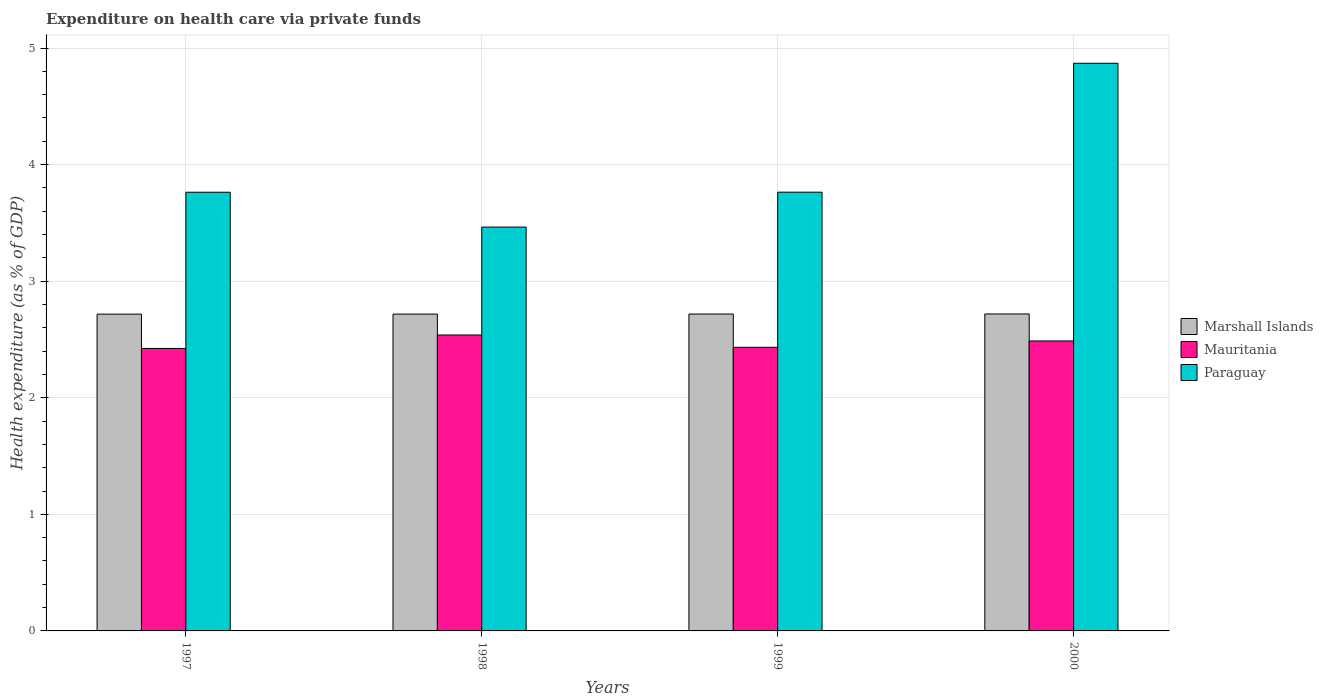How many groups of bars are there?
Your response must be concise. 4. Are the number of bars on each tick of the X-axis equal?
Provide a short and direct response. Yes. How many bars are there on the 2nd tick from the left?
Your answer should be very brief. 3. How many bars are there on the 3rd tick from the right?
Keep it short and to the point. 3. What is the expenditure made on health care in Paraguay in 1997?
Offer a very short reply. 3.76. Across all years, what is the maximum expenditure made on health care in Mauritania?
Your response must be concise. 2.54. Across all years, what is the minimum expenditure made on health care in Mauritania?
Your answer should be compact. 2.42. In which year was the expenditure made on health care in Paraguay maximum?
Your answer should be very brief. 2000. What is the total expenditure made on health care in Mauritania in the graph?
Keep it short and to the point. 9.88. What is the difference between the expenditure made on health care in Marshall Islands in 1997 and that in 1999?
Provide a short and direct response. -0. What is the difference between the expenditure made on health care in Marshall Islands in 2000 and the expenditure made on health care in Mauritania in 1998?
Your answer should be very brief. 0.18. What is the average expenditure made on health care in Mauritania per year?
Your answer should be compact. 2.47. In the year 1997, what is the difference between the expenditure made on health care in Paraguay and expenditure made on health care in Marshall Islands?
Provide a succinct answer. 1.05. In how many years, is the expenditure made on health care in Paraguay greater than 2.4 %?
Your response must be concise. 4. What is the ratio of the expenditure made on health care in Mauritania in 1997 to that in 2000?
Make the answer very short. 0.97. Is the difference between the expenditure made on health care in Paraguay in 1998 and 1999 greater than the difference between the expenditure made on health care in Marshall Islands in 1998 and 1999?
Ensure brevity in your answer.  No. What is the difference between the highest and the second highest expenditure made on health care in Marshall Islands?
Ensure brevity in your answer.  0. What is the difference between the highest and the lowest expenditure made on health care in Paraguay?
Offer a terse response. 1.41. Is the sum of the expenditure made on health care in Marshall Islands in 1997 and 2000 greater than the maximum expenditure made on health care in Paraguay across all years?
Keep it short and to the point. Yes. What does the 1st bar from the left in 1999 represents?
Make the answer very short. Marshall Islands. What does the 2nd bar from the right in 2000 represents?
Offer a terse response. Mauritania. How many years are there in the graph?
Provide a succinct answer. 4. What is the difference between two consecutive major ticks on the Y-axis?
Ensure brevity in your answer.  1. Are the values on the major ticks of Y-axis written in scientific E-notation?
Provide a short and direct response. No. Does the graph contain grids?
Make the answer very short. Yes. What is the title of the graph?
Offer a very short reply. Expenditure on health care via private funds. Does "Syrian Arab Republic" appear as one of the legend labels in the graph?
Provide a succinct answer. No. What is the label or title of the Y-axis?
Your response must be concise. Health expenditure (as % of GDP). What is the Health expenditure (as % of GDP) of Marshall Islands in 1997?
Offer a very short reply. 2.72. What is the Health expenditure (as % of GDP) of Mauritania in 1997?
Your response must be concise. 2.42. What is the Health expenditure (as % of GDP) in Paraguay in 1997?
Make the answer very short. 3.76. What is the Health expenditure (as % of GDP) of Marshall Islands in 1998?
Your response must be concise. 2.72. What is the Health expenditure (as % of GDP) in Mauritania in 1998?
Offer a terse response. 2.54. What is the Health expenditure (as % of GDP) of Paraguay in 1998?
Your answer should be very brief. 3.46. What is the Health expenditure (as % of GDP) of Marshall Islands in 1999?
Keep it short and to the point. 2.72. What is the Health expenditure (as % of GDP) of Mauritania in 1999?
Offer a very short reply. 2.43. What is the Health expenditure (as % of GDP) in Paraguay in 1999?
Provide a succinct answer. 3.76. What is the Health expenditure (as % of GDP) in Marshall Islands in 2000?
Give a very brief answer. 2.72. What is the Health expenditure (as % of GDP) in Mauritania in 2000?
Your answer should be very brief. 2.49. What is the Health expenditure (as % of GDP) of Paraguay in 2000?
Provide a succinct answer. 4.87. Across all years, what is the maximum Health expenditure (as % of GDP) in Marshall Islands?
Ensure brevity in your answer.  2.72. Across all years, what is the maximum Health expenditure (as % of GDP) of Mauritania?
Keep it short and to the point. 2.54. Across all years, what is the maximum Health expenditure (as % of GDP) in Paraguay?
Your answer should be compact. 4.87. Across all years, what is the minimum Health expenditure (as % of GDP) of Marshall Islands?
Make the answer very short. 2.72. Across all years, what is the minimum Health expenditure (as % of GDP) of Mauritania?
Offer a terse response. 2.42. Across all years, what is the minimum Health expenditure (as % of GDP) of Paraguay?
Ensure brevity in your answer.  3.46. What is the total Health expenditure (as % of GDP) in Marshall Islands in the graph?
Offer a terse response. 10.87. What is the total Health expenditure (as % of GDP) of Mauritania in the graph?
Your response must be concise. 9.88. What is the total Health expenditure (as % of GDP) of Paraguay in the graph?
Provide a short and direct response. 15.86. What is the difference between the Health expenditure (as % of GDP) of Marshall Islands in 1997 and that in 1998?
Your response must be concise. -0. What is the difference between the Health expenditure (as % of GDP) in Mauritania in 1997 and that in 1998?
Offer a terse response. -0.12. What is the difference between the Health expenditure (as % of GDP) of Paraguay in 1997 and that in 1998?
Provide a succinct answer. 0.3. What is the difference between the Health expenditure (as % of GDP) of Marshall Islands in 1997 and that in 1999?
Make the answer very short. -0. What is the difference between the Health expenditure (as % of GDP) of Mauritania in 1997 and that in 1999?
Offer a terse response. -0.01. What is the difference between the Health expenditure (as % of GDP) of Paraguay in 1997 and that in 1999?
Make the answer very short. -0. What is the difference between the Health expenditure (as % of GDP) in Marshall Islands in 1997 and that in 2000?
Your answer should be compact. -0. What is the difference between the Health expenditure (as % of GDP) of Mauritania in 1997 and that in 2000?
Provide a succinct answer. -0.06. What is the difference between the Health expenditure (as % of GDP) of Paraguay in 1997 and that in 2000?
Keep it short and to the point. -1.11. What is the difference between the Health expenditure (as % of GDP) in Marshall Islands in 1998 and that in 1999?
Provide a succinct answer. -0. What is the difference between the Health expenditure (as % of GDP) of Mauritania in 1998 and that in 1999?
Ensure brevity in your answer.  0.11. What is the difference between the Health expenditure (as % of GDP) in Paraguay in 1998 and that in 1999?
Your answer should be very brief. -0.3. What is the difference between the Health expenditure (as % of GDP) in Marshall Islands in 1998 and that in 2000?
Your answer should be very brief. -0. What is the difference between the Health expenditure (as % of GDP) of Mauritania in 1998 and that in 2000?
Make the answer very short. 0.05. What is the difference between the Health expenditure (as % of GDP) of Paraguay in 1998 and that in 2000?
Your answer should be compact. -1.41. What is the difference between the Health expenditure (as % of GDP) in Marshall Islands in 1999 and that in 2000?
Make the answer very short. -0. What is the difference between the Health expenditure (as % of GDP) of Mauritania in 1999 and that in 2000?
Make the answer very short. -0.05. What is the difference between the Health expenditure (as % of GDP) in Paraguay in 1999 and that in 2000?
Keep it short and to the point. -1.11. What is the difference between the Health expenditure (as % of GDP) of Marshall Islands in 1997 and the Health expenditure (as % of GDP) of Mauritania in 1998?
Offer a very short reply. 0.18. What is the difference between the Health expenditure (as % of GDP) in Marshall Islands in 1997 and the Health expenditure (as % of GDP) in Paraguay in 1998?
Give a very brief answer. -0.75. What is the difference between the Health expenditure (as % of GDP) in Mauritania in 1997 and the Health expenditure (as % of GDP) in Paraguay in 1998?
Provide a short and direct response. -1.04. What is the difference between the Health expenditure (as % of GDP) of Marshall Islands in 1997 and the Health expenditure (as % of GDP) of Mauritania in 1999?
Offer a very short reply. 0.28. What is the difference between the Health expenditure (as % of GDP) of Marshall Islands in 1997 and the Health expenditure (as % of GDP) of Paraguay in 1999?
Give a very brief answer. -1.05. What is the difference between the Health expenditure (as % of GDP) in Mauritania in 1997 and the Health expenditure (as % of GDP) in Paraguay in 1999?
Provide a short and direct response. -1.34. What is the difference between the Health expenditure (as % of GDP) in Marshall Islands in 1997 and the Health expenditure (as % of GDP) in Mauritania in 2000?
Offer a terse response. 0.23. What is the difference between the Health expenditure (as % of GDP) of Marshall Islands in 1997 and the Health expenditure (as % of GDP) of Paraguay in 2000?
Your answer should be compact. -2.15. What is the difference between the Health expenditure (as % of GDP) in Mauritania in 1997 and the Health expenditure (as % of GDP) in Paraguay in 2000?
Give a very brief answer. -2.45. What is the difference between the Health expenditure (as % of GDP) of Marshall Islands in 1998 and the Health expenditure (as % of GDP) of Mauritania in 1999?
Your answer should be compact. 0.28. What is the difference between the Health expenditure (as % of GDP) in Marshall Islands in 1998 and the Health expenditure (as % of GDP) in Paraguay in 1999?
Ensure brevity in your answer.  -1.05. What is the difference between the Health expenditure (as % of GDP) of Mauritania in 1998 and the Health expenditure (as % of GDP) of Paraguay in 1999?
Give a very brief answer. -1.22. What is the difference between the Health expenditure (as % of GDP) of Marshall Islands in 1998 and the Health expenditure (as % of GDP) of Mauritania in 2000?
Offer a very short reply. 0.23. What is the difference between the Health expenditure (as % of GDP) of Marshall Islands in 1998 and the Health expenditure (as % of GDP) of Paraguay in 2000?
Offer a very short reply. -2.15. What is the difference between the Health expenditure (as % of GDP) of Mauritania in 1998 and the Health expenditure (as % of GDP) of Paraguay in 2000?
Ensure brevity in your answer.  -2.33. What is the difference between the Health expenditure (as % of GDP) of Marshall Islands in 1999 and the Health expenditure (as % of GDP) of Mauritania in 2000?
Provide a short and direct response. 0.23. What is the difference between the Health expenditure (as % of GDP) of Marshall Islands in 1999 and the Health expenditure (as % of GDP) of Paraguay in 2000?
Offer a terse response. -2.15. What is the difference between the Health expenditure (as % of GDP) of Mauritania in 1999 and the Health expenditure (as % of GDP) of Paraguay in 2000?
Provide a succinct answer. -2.44. What is the average Health expenditure (as % of GDP) in Marshall Islands per year?
Ensure brevity in your answer.  2.72. What is the average Health expenditure (as % of GDP) in Mauritania per year?
Provide a short and direct response. 2.47. What is the average Health expenditure (as % of GDP) of Paraguay per year?
Offer a very short reply. 3.97. In the year 1997, what is the difference between the Health expenditure (as % of GDP) of Marshall Islands and Health expenditure (as % of GDP) of Mauritania?
Ensure brevity in your answer.  0.29. In the year 1997, what is the difference between the Health expenditure (as % of GDP) in Marshall Islands and Health expenditure (as % of GDP) in Paraguay?
Make the answer very short. -1.05. In the year 1997, what is the difference between the Health expenditure (as % of GDP) of Mauritania and Health expenditure (as % of GDP) of Paraguay?
Make the answer very short. -1.34. In the year 1998, what is the difference between the Health expenditure (as % of GDP) of Marshall Islands and Health expenditure (as % of GDP) of Mauritania?
Your answer should be compact. 0.18. In the year 1998, what is the difference between the Health expenditure (as % of GDP) in Marshall Islands and Health expenditure (as % of GDP) in Paraguay?
Offer a very short reply. -0.75. In the year 1998, what is the difference between the Health expenditure (as % of GDP) in Mauritania and Health expenditure (as % of GDP) in Paraguay?
Keep it short and to the point. -0.93. In the year 1999, what is the difference between the Health expenditure (as % of GDP) of Marshall Islands and Health expenditure (as % of GDP) of Mauritania?
Offer a very short reply. 0.29. In the year 1999, what is the difference between the Health expenditure (as % of GDP) in Marshall Islands and Health expenditure (as % of GDP) in Paraguay?
Give a very brief answer. -1.05. In the year 1999, what is the difference between the Health expenditure (as % of GDP) of Mauritania and Health expenditure (as % of GDP) of Paraguay?
Keep it short and to the point. -1.33. In the year 2000, what is the difference between the Health expenditure (as % of GDP) of Marshall Islands and Health expenditure (as % of GDP) of Mauritania?
Offer a very short reply. 0.23. In the year 2000, what is the difference between the Health expenditure (as % of GDP) of Marshall Islands and Health expenditure (as % of GDP) of Paraguay?
Make the answer very short. -2.15. In the year 2000, what is the difference between the Health expenditure (as % of GDP) in Mauritania and Health expenditure (as % of GDP) in Paraguay?
Ensure brevity in your answer.  -2.38. What is the ratio of the Health expenditure (as % of GDP) of Marshall Islands in 1997 to that in 1998?
Offer a terse response. 1. What is the ratio of the Health expenditure (as % of GDP) in Mauritania in 1997 to that in 1998?
Make the answer very short. 0.95. What is the ratio of the Health expenditure (as % of GDP) in Paraguay in 1997 to that in 1998?
Ensure brevity in your answer.  1.09. What is the ratio of the Health expenditure (as % of GDP) in Marshall Islands in 1997 to that in 2000?
Your answer should be compact. 1. What is the ratio of the Health expenditure (as % of GDP) in Mauritania in 1997 to that in 2000?
Offer a very short reply. 0.97. What is the ratio of the Health expenditure (as % of GDP) in Paraguay in 1997 to that in 2000?
Offer a terse response. 0.77. What is the ratio of the Health expenditure (as % of GDP) in Mauritania in 1998 to that in 1999?
Give a very brief answer. 1.04. What is the ratio of the Health expenditure (as % of GDP) in Paraguay in 1998 to that in 1999?
Give a very brief answer. 0.92. What is the ratio of the Health expenditure (as % of GDP) of Marshall Islands in 1998 to that in 2000?
Your response must be concise. 1. What is the ratio of the Health expenditure (as % of GDP) in Mauritania in 1998 to that in 2000?
Provide a succinct answer. 1.02. What is the ratio of the Health expenditure (as % of GDP) in Paraguay in 1998 to that in 2000?
Ensure brevity in your answer.  0.71. What is the ratio of the Health expenditure (as % of GDP) in Marshall Islands in 1999 to that in 2000?
Ensure brevity in your answer.  1. What is the ratio of the Health expenditure (as % of GDP) of Mauritania in 1999 to that in 2000?
Your answer should be very brief. 0.98. What is the ratio of the Health expenditure (as % of GDP) of Paraguay in 1999 to that in 2000?
Offer a terse response. 0.77. What is the difference between the highest and the second highest Health expenditure (as % of GDP) in Marshall Islands?
Give a very brief answer. 0. What is the difference between the highest and the second highest Health expenditure (as % of GDP) in Mauritania?
Offer a terse response. 0.05. What is the difference between the highest and the second highest Health expenditure (as % of GDP) in Paraguay?
Keep it short and to the point. 1.11. What is the difference between the highest and the lowest Health expenditure (as % of GDP) in Marshall Islands?
Provide a short and direct response. 0. What is the difference between the highest and the lowest Health expenditure (as % of GDP) in Mauritania?
Ensure brevity in your answer.  0.12. What is the difference between the highest and the lowest Health expenditure (as % of GDP) in Paraguay?
Offer a terse response. 1.41. 